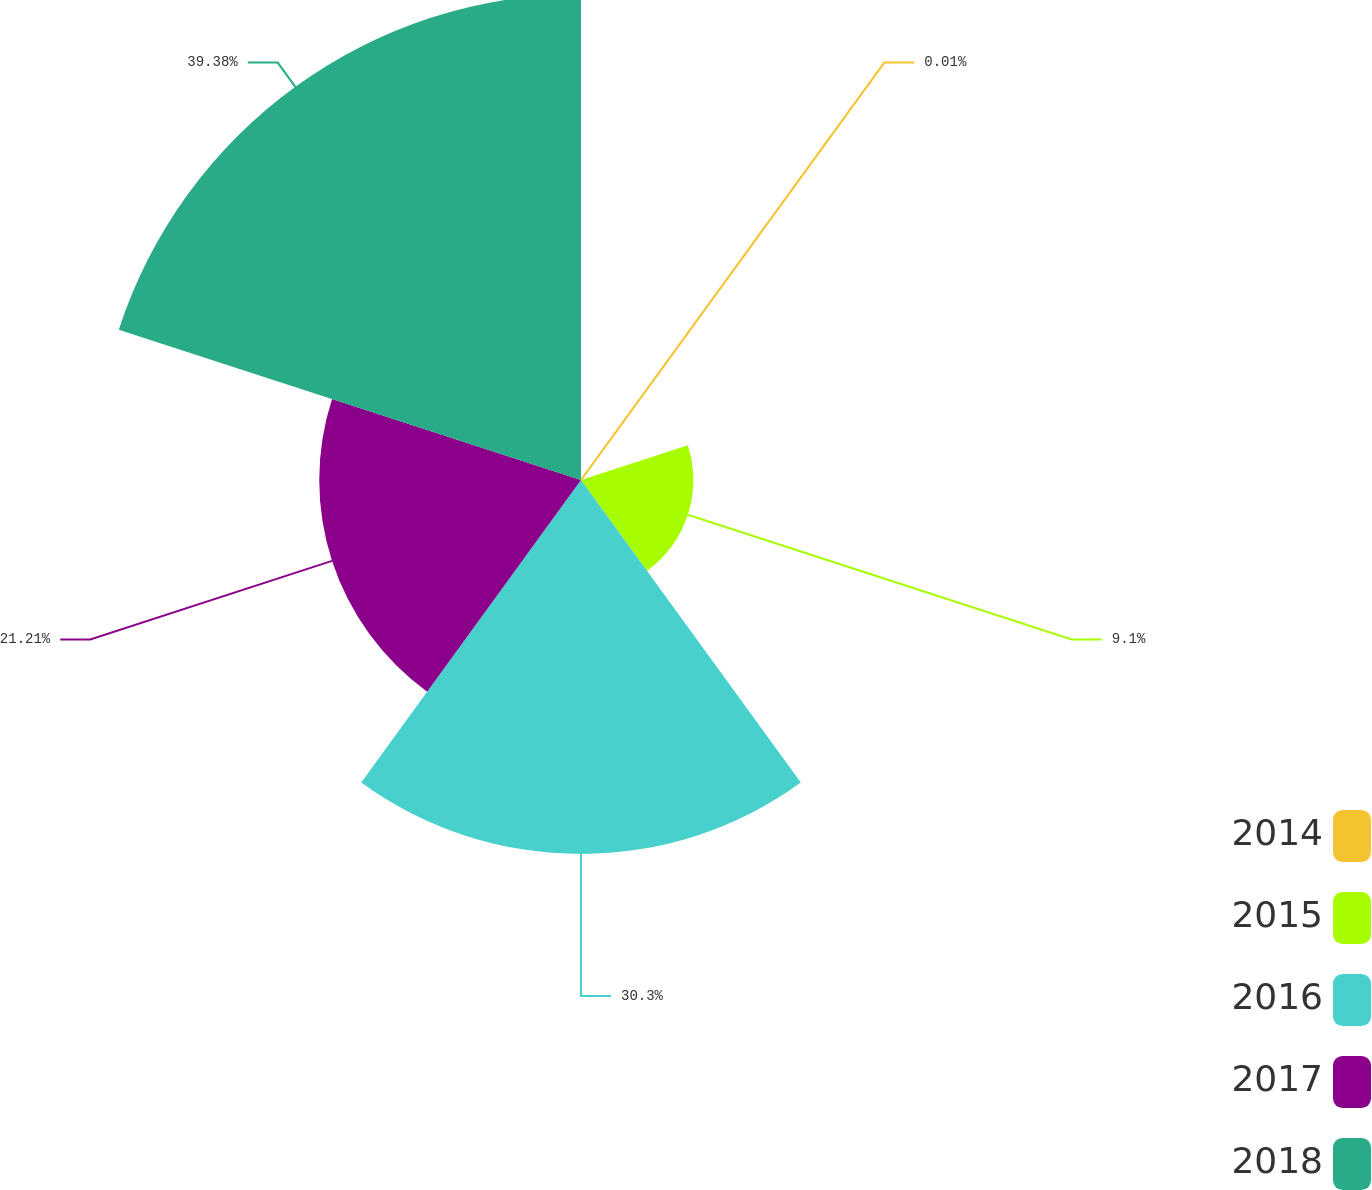Convert chart to OTSL. <chart><loc_0><loc_0><loc_500><loc_500><pie_chart><fcel>2014<fcel>2015<fcel>2016<fcel>2017<fcel>2018<nl><fcel>0.01%<fcel>9.1%<fcel>30.3%<fcel>21.21%<fcel>39.38%<nl></chart> 